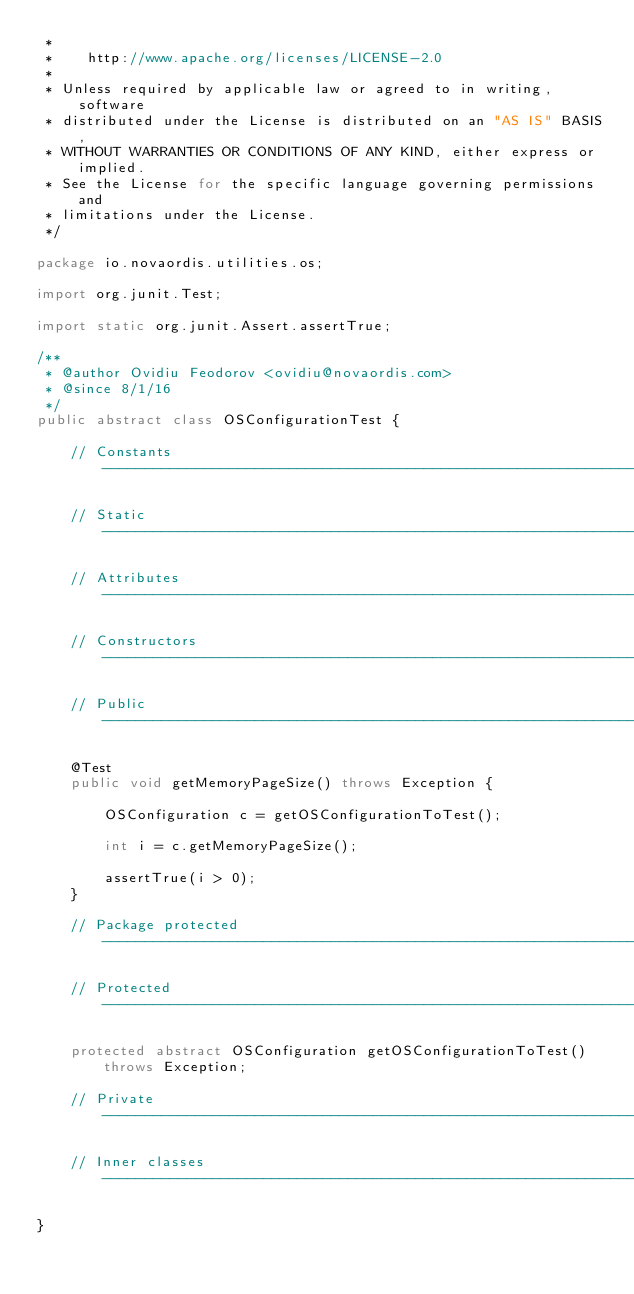Convert code to text. <code><loc_0><loc_0><loc_500><loc_500><_Java_> *
 *    http://www.apache.org/licenses/LICENSE-2.0
 *
 * Unless required by applicable law or agreed to in writing, software
 * distributed under the License is distributed on an "AS IS" BASIS,
 * WITHOUT WARRANTIES OR CONDITIONS OF ANY KIND, either express or implied.
 * See the License for the specific language governing permissions and
 * limitations under the License.
 */

package io.novaordis.utilities.os;

import org.junit.Test;

import static org.junit.Assert.assertTrue;

/**
 * @author Ovidiu Feodorov <ovidiu@novaordis.com>
 * @since 8/1/16
 */
public abstract class OSConfigurationTest {

    // Constants -------------------------------------------------------------------------------------------------------

    // Static ----------------------------------------------------------------------------------------------------------

    // Attributes ------------------------------------------------------------------------------------------------------

    // Constructors ----------------------------------------------------------------------------------------------------

    // Public ----------------------------------------------------------------------------------------------------------

    @Test
    public void getMemoryPageSize() throws Exception {

        OSConfiguration c = getOSConfigurationToTest();

        int i = c.getMemoryPageSize();

        assertTrue(i > 0);
    }

    // Package protected -----------------------------------------------------------------------------------------------

    // Protected -------------------------------------------------------------------------------------------------------

    protected abstract OSConfiguration getOSConfigurationToTest() throws Exception;

    // Private ---------------------------------------------------------------------------------------------------------

    // Inner classes ---------------------------------------------------------------------------------------------------

}
</code> 